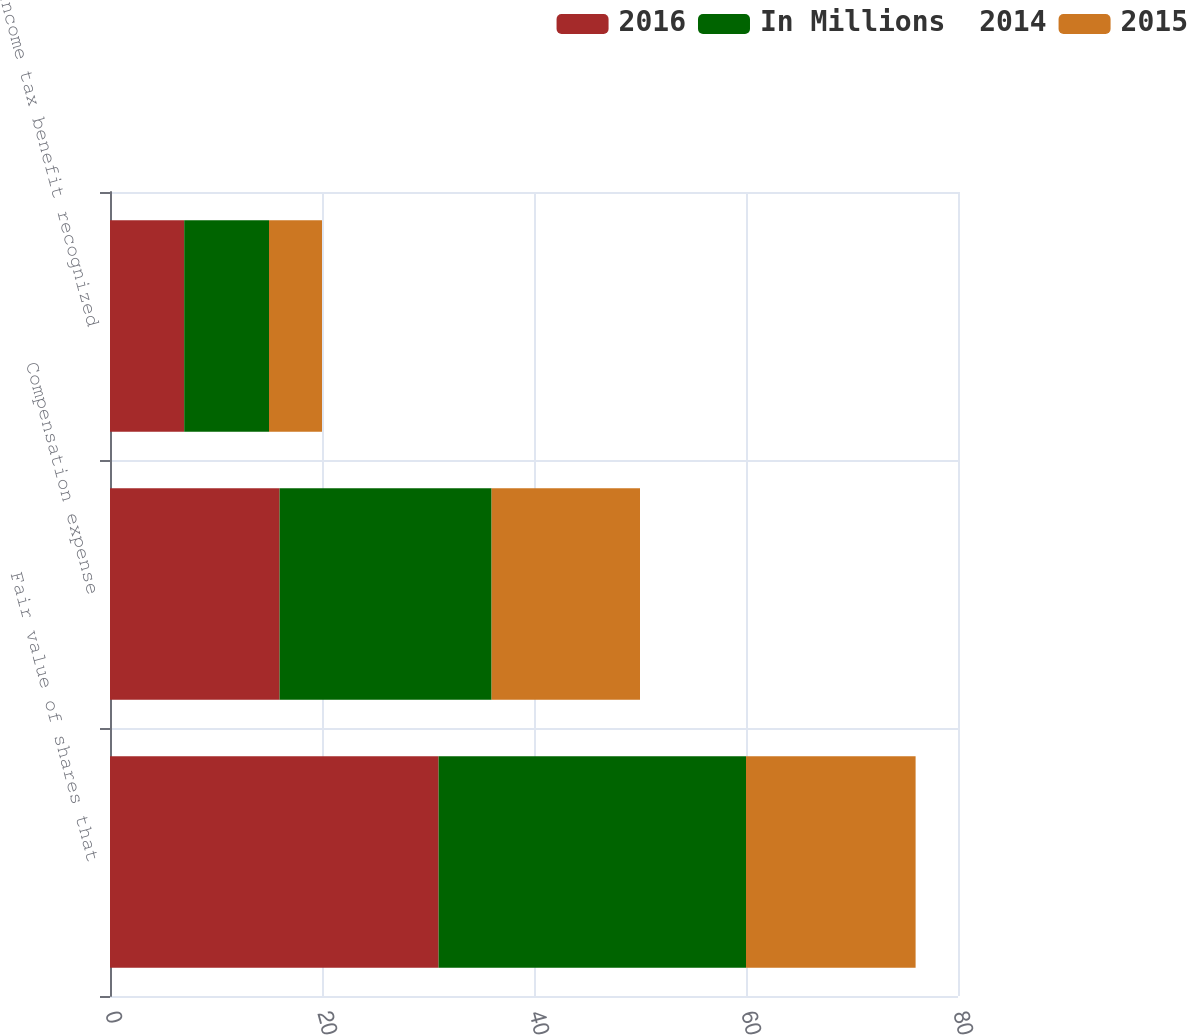Convert chart. <chart><loc_0><loc_0><loc_500><loc_500><stacked_bar_chart><ecel><fcel>Fair value of shares that<fcel>Compensation expense<fcel>Income tax benefit recognized<nl><fcel>2016<fcel>31<fcel>16<fcel>7<nl><fcel>In Millions  2014<fcel>29<fcel>20<fcel>8<nl><fcel>2015<fcel>16<fcel>14<fcel>5<nl></chart> 